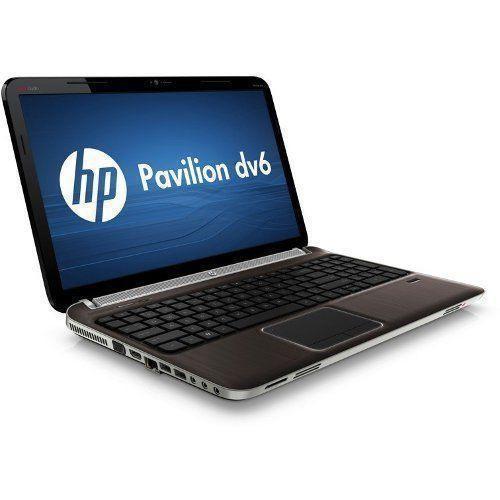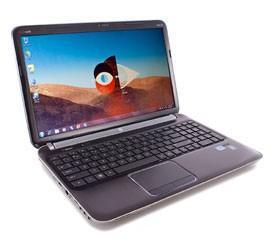The first image is the image on the left, the second image is the image on the right. Given the left and right images, does the statement "there is a laptop with a screen showing a windows logo with light shining through the window" hold true? Answer yes or no. No. The first image is the image on the left, the second image is the image on the right. Analyze the images presented: Is the assertion "All laptops are angled with the open screen facing rightward, and one laptop features a blue screen with a white circle logo on it." valid? Answer yes or no. Yes. 